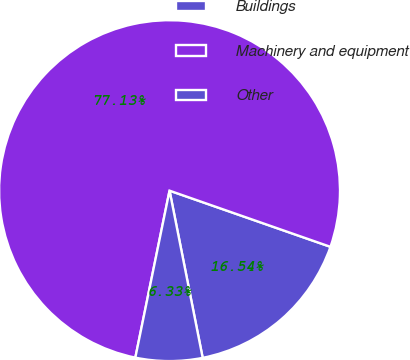Convert chart to OTSL. <chart><loc_0><loc_0><loc_500><loc_500><pie_chart><fcel>Buildings<fcel>Machinery and equipment<fcel>Other<nl><fcel>16.54%<fcel>77.13%<fcel>6.33%<nl></chart> 